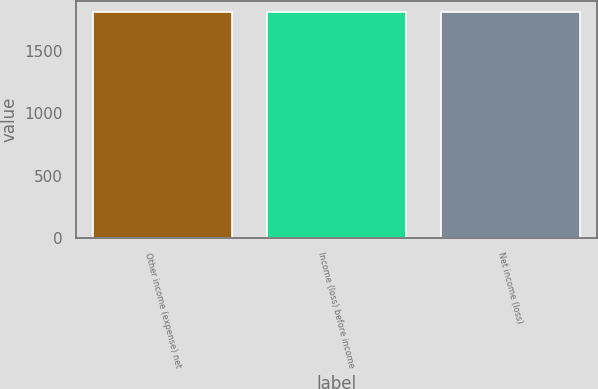Convert chart. <chart><loc_0><loc_0><loc_500><loc_500><bar_chart><fcel>Other income (expense) net<fcel>Income (loss) before income<fcel>Net income (loss)<nl><fcel>1807<fcel>1807.1<fcel>1807.2<nl></chart> 